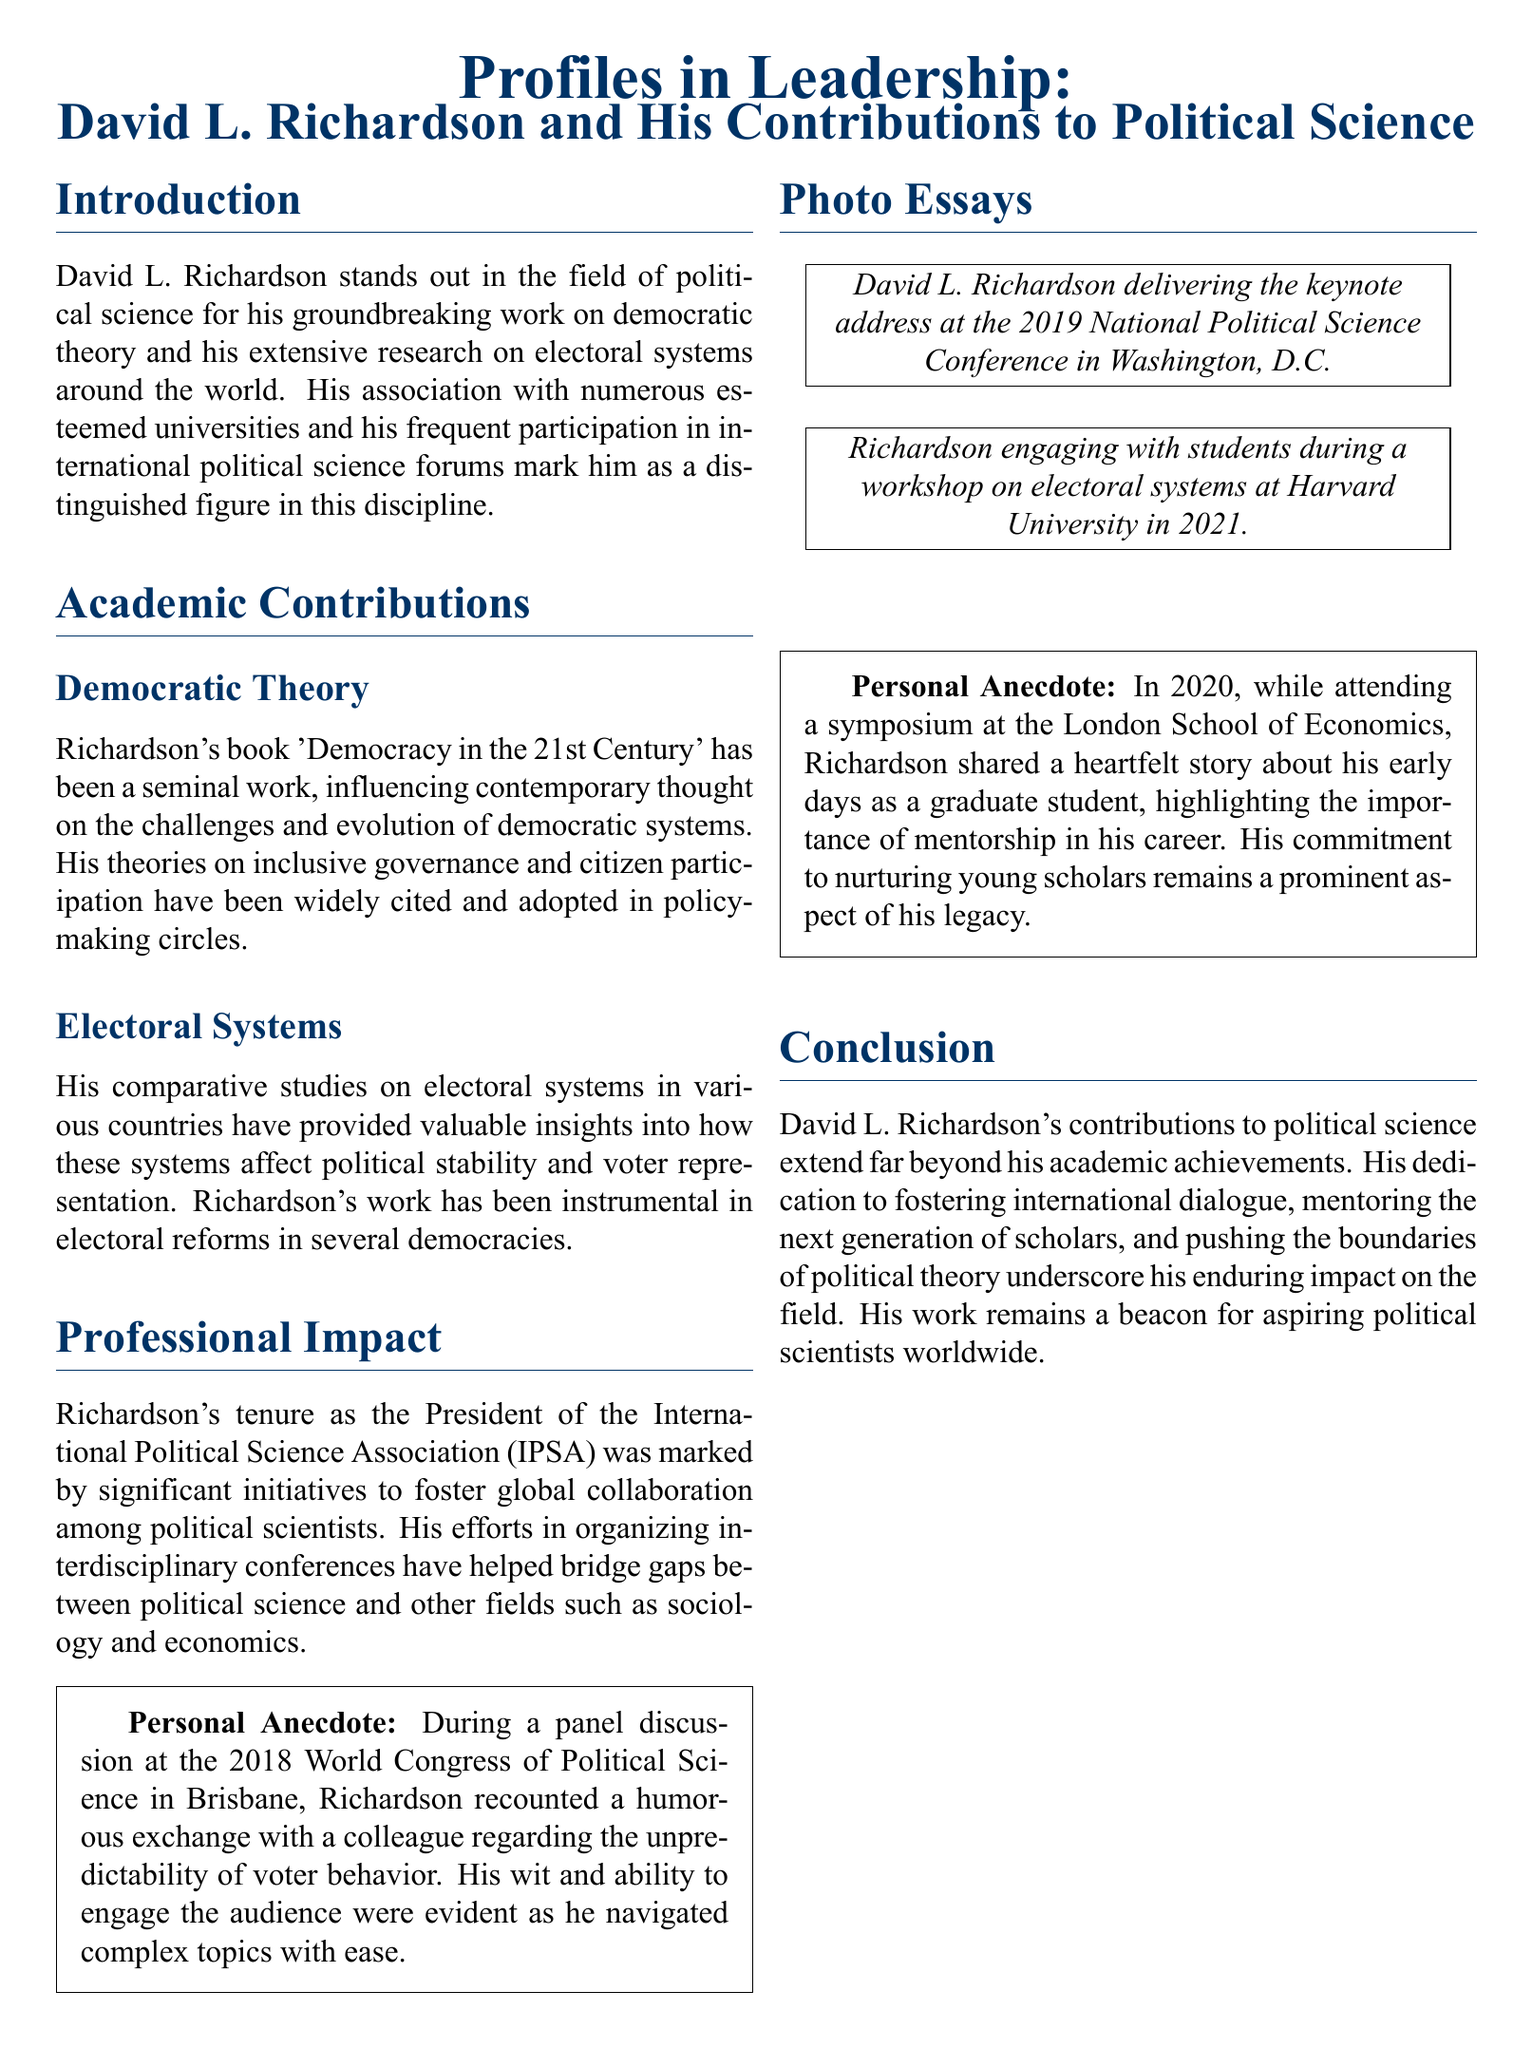What is the title of David L. Richardson's book? The title of the book is mentioned in the section on Democratic Theory.
Answer: Democracy in the 21st Century What organization did Richardson serve as President? The organization is indicated in the Professional Impact section.
Answer: International Political Science Association In which year did Richardson deliver a keynote address in Washington, D.C.? The year is specified within the Photo Essays section.
Answer: 2019 What major theme does Richardson focus on in his work? The theme is central to his contributions to political science as stated in the introduction and academic contributions sections.
Answer: Democratic theory What city hosted the World Congress of Political Science in which Richardson participated? The city is mentioned in a personal anecdote related to a panel discussion.
Answer: Brisbane In what year did Richardson engage with students during a workshop at Harvard University? The year of the event is specified in the Photo Essays section.
Answer: 2021 What important value did Richardson highlight in his story about mentorship? This value is highlighted in the anecdote shared during the symposium.
Answer: Importance How does Richardson's work influence aspiring political scientists? This influence is discussed in the conclusion, summarizing his impact on the field.
Answer: Beacon 